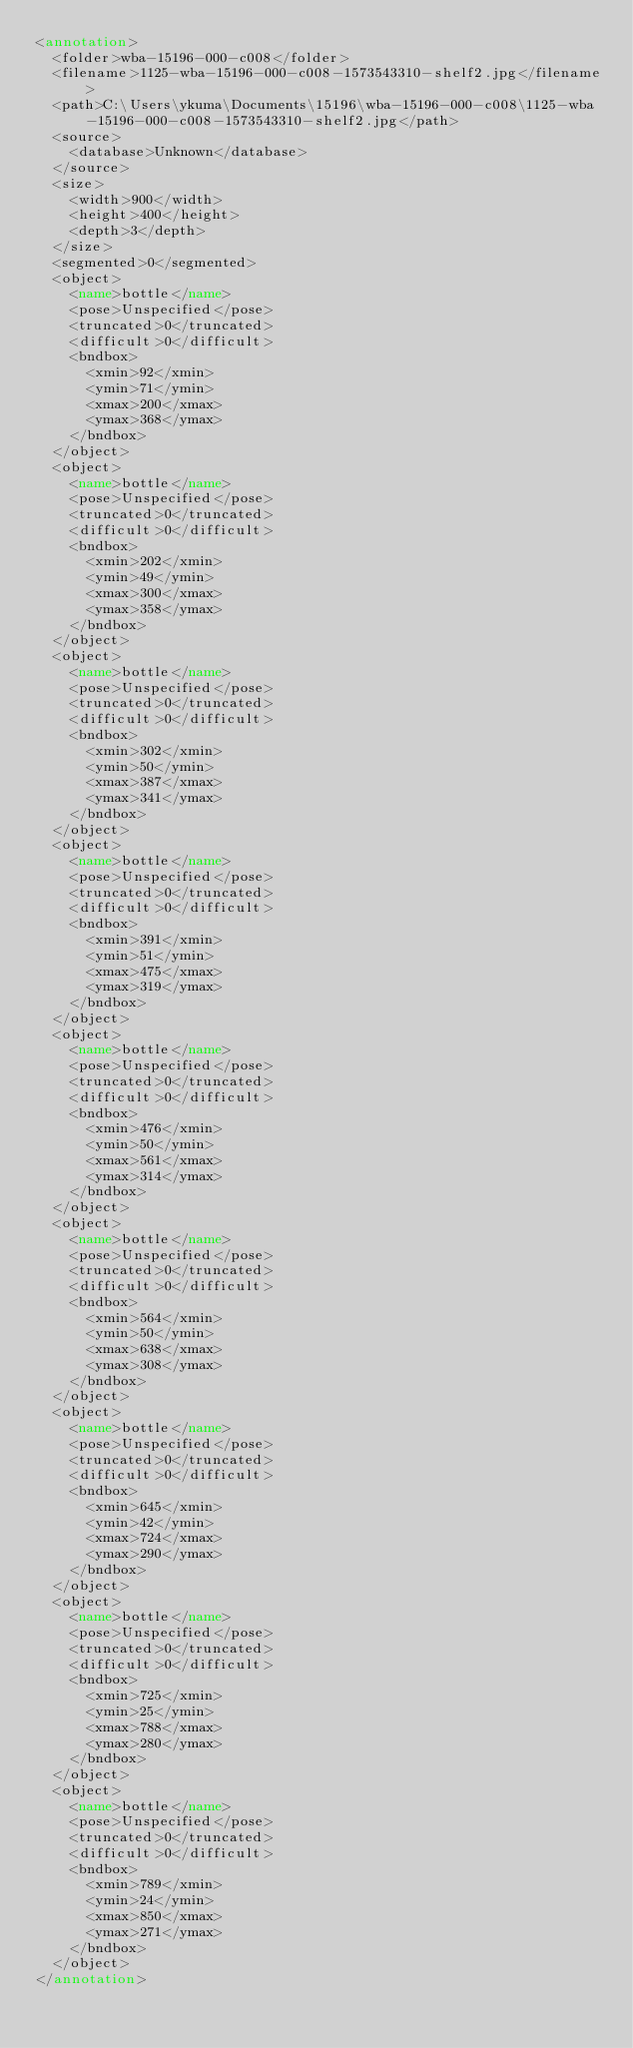<code> <loc_0><loc_0><loc_500><loc_500><_XML_><annotation>
	<folder>wba-15196-000-c008</folder>
	<filename>1125-wba-15196-000-c008-1573543310-shelf2.jpg</filename>
	<path>C:\Users\ykuma\Documents\15196\wba-15196-000-c008\1125-wba-15196-000-c008-1573543310-shelf2.jpg</path>
	<source>
		<database>Unknown</database>
	</source>
	<size>
		<width>900</width>
		<height>400</height>
		<depth>3</depth>
	</size>
	<segmented>0</segmented>
	<object>
		<name>bottle</name>
		<pose>Unspecified</pose>
		<truncated>0</truncated>
		<difficult>0</difficult>
		<bndbox>
			<xmin>92</xmin>
			<ymin>71</ymin>
			<xmax>200</xmax>
			<ymax>368</ymax>
		</bndbox>
	</object>
	<object>
		<name>bottle</name>
		<pose>Unspecified</pose>
		<truncated>0</truncated>
		<difficult>0</difficult>
		<bndbox>
			<xmin>202</xmin>
			<ymin>49</ymin>
			<xmax>300</xmax>
			<ymax>358</ymax>
		</bndbox>
	</object>
	<object>
		<name>bottle</name>
		<pose>Unspecified</pose>
		<truncated>0</truncated>
		<difficult>0</difficult>
		<bndbox>
			<xmin>302</xmin>
			<ymin>50</ymin>
			<xmax>387</xmax>
			<ymax>341</ymax>
		</bndbox>
	</object>
	<object>
		<name>bottle</name>
		<pose>Unspecified</pose>
		<truncated>0</truncated>
		<difficult>0</difficult>
		<bndbox>
			<xmin>391</xmin>
			<ymin>51</ymin>
			<xmax>475</xmax>
			<ymax>319</ymax>
		</bndbox>
	</object>
	<object>
		<name>bottle</name>
		<pose>Unspecified</pose>
		<truncated>0</truncated>
		<difficult>0</difficult>
		<bndbox>
			<xmin>476</xmin>
			<ymin>50</ymin>
			<xmax>561</xmax>
			<ymax>314</ymax>
		</bndbox>
	</object>
	<object>
		<name>bottle</name>
		<pose>Unspecified</pose>
		<truncated>0</truncated>
		<difficult>0</difficult>
		<bndbox>
			<xmin>564</xmin>
			<ymin>50</ymin>
			<xmax>638</xmax>
			<ymax>308</ymax>
		</bndbox>
	</object>
	<object>
		<name>bottle</name>
		<pose>Unspecified</pose>
		<truncated>0</truncated>
		<difficult>0</difficult>
		<bndbox>
			<xmin>645</xmin>
			<ymin>42</ymin>
			<xmax>724</xmax>
			<ymax>290</ymax>
		</bndbox>
	</object>
	<object>
		<name>bottle</name>
		<pose>Unspecified</pose>
		<truncated>0</truncated>
		<difficult>0</difficult>
		<bndbox>
			<xmin>725</xmin>
			<ymin>25</ymin>
			<xmax>788</xmax>
			<ymax>280</ymax>
		</bndbox>
	</object>
	<object>
		<name>bottle</name>
		<pose>Unspecified</pose>
		<truncated>0</truncated>
		<difficult>0</difficult>
		<bndbox>
			<xmin>789</xmin>
			<ymin>24</ymin>
			<xmax>850</xmax>
			<ymax>271</ymax>
		</bndbox>
	</object>
</annotation></code> 